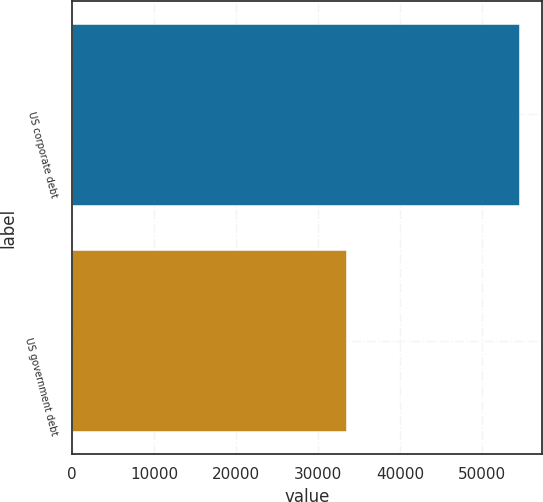Convert chart. <chart><loc_0><loc_0><loc_500><loc_500><bar_chart><fcel>US corporate debt<fcel>US government debt<nl><fcel>54577<fcel>33468<nl></chart> 